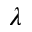Convert formula to latex. <formula><loc_0><loc_0><loc_500><loc_500>\lambda</formula> 